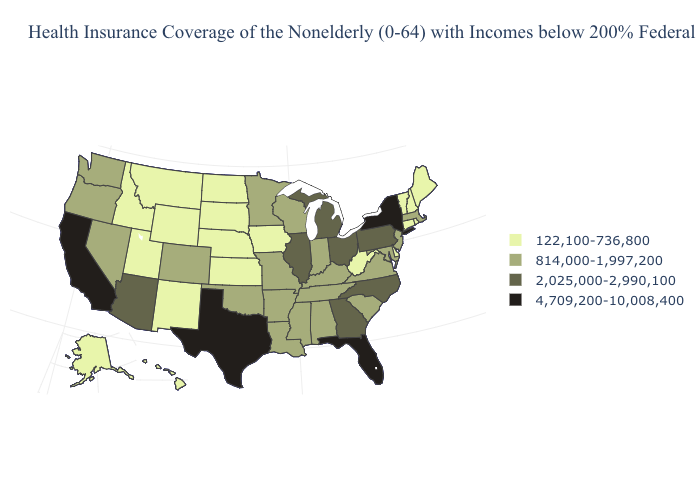Does Idaho have the lowest value in the USA?
Give a very brief answer. Yes. Does Texas have the highest value in the USA?
Answer briefly. Yes. Name the states that have a value in the range 122,100-736,800?
Keep it brief. Alaska, Connecticut, Delaware, Hawaii, Idaho, Iowa, Kansas, Maine, Montana, Nebraska, New Hampshire, New Mexico, North Dakota, Rhode Island, South Dakota, Utah, Vermont, West Virginia, Wyoming. Name the states that have a value in the range 2,025,000-2,990,100?
Quick response, please. Arizona, Georgia, Illinois, Michigan, North Carolina, Ohio, Pennsylvania. What is the lowest value in the USA?
Short answer required. 122,100-736,800. Does New York have the lowest value in the Northeast?
Keep it brief. No. What is the highest value in the South ?
Keep it brief. 4,709,200-10,008,400. Does Missouri have the lowest value in the MidWest?
Give a very brief answer. No. Among the states that border Oklahoma , which have the lowest value?
Short answer required. Kansas, New Mexico. Does Florida have the highest value in the USA?
Give a very brief answer. Yes. Among the states that border Rhode Island , which have the lowest value?
Keep it brief. Connecticut. Name the states that have a value in the range 122,100-736,800?
Quick response, please. Alaska, Connecticut, Delaware, Hawaii, Idaho, Iowa, Kansas, Maine, Montana, Nebraska, New Hampshire, New Mexico, North Dakota, Rhode Island, South Dakota, Utah, Vermont, West Virginia, Wyoming. What is the value of Utah?
Answer briefly. 122,100-736,800. What is the lowest value in the USA?
Keep it brief. 122,100-736,800. What is the highest value in the USA?
Be succinct. 4,709,200-10,008,400. 